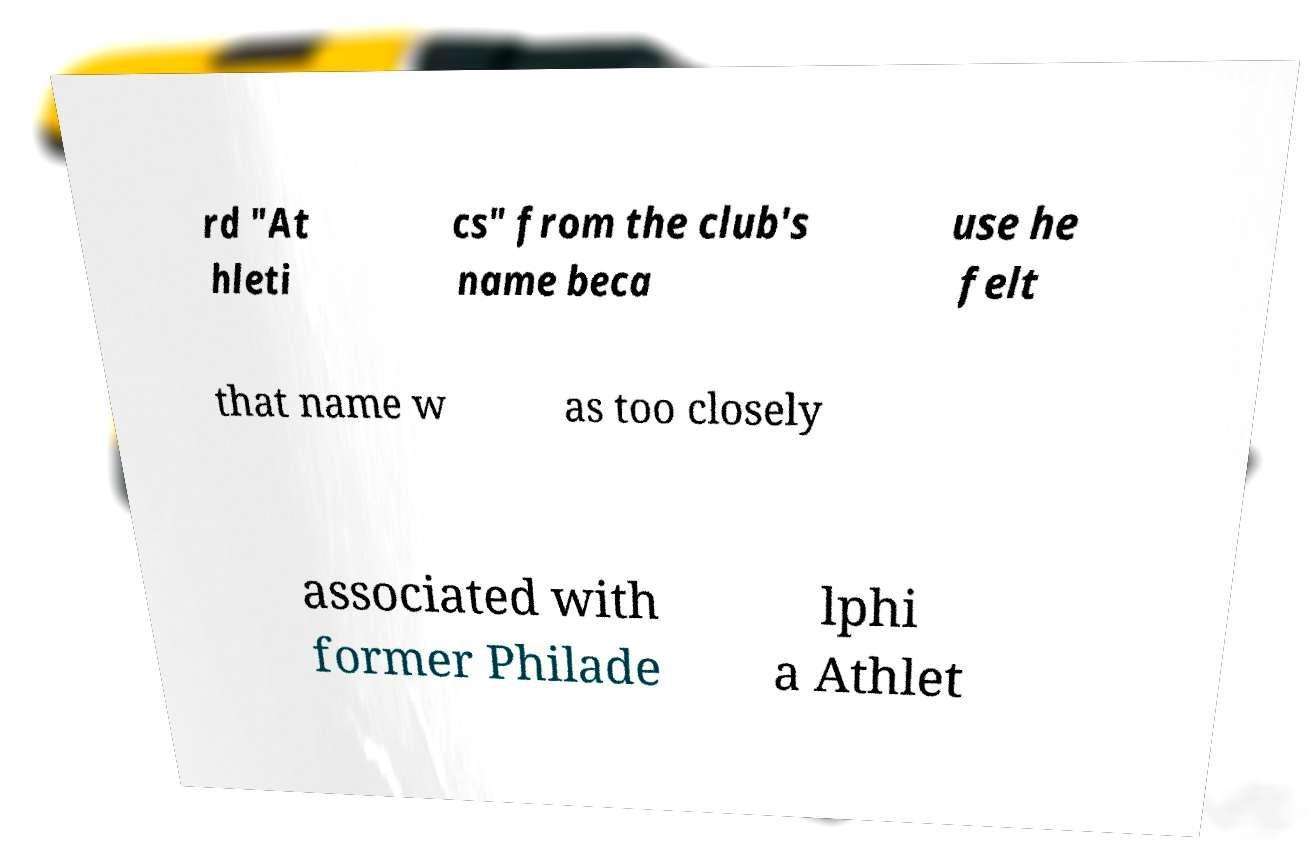Could you assist in decoding the text presented in this image and type it out clearly? rd "At hleti cs" from the club's name beca use he felt that name w as too closely associated with former Philade lphi a Athlet 